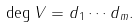Convert formula to latex. <formula><loc_0><loc_0><loc_500><loc_500>\deg V = d _ { 1 } \cdots d _ { m } .</formula> 